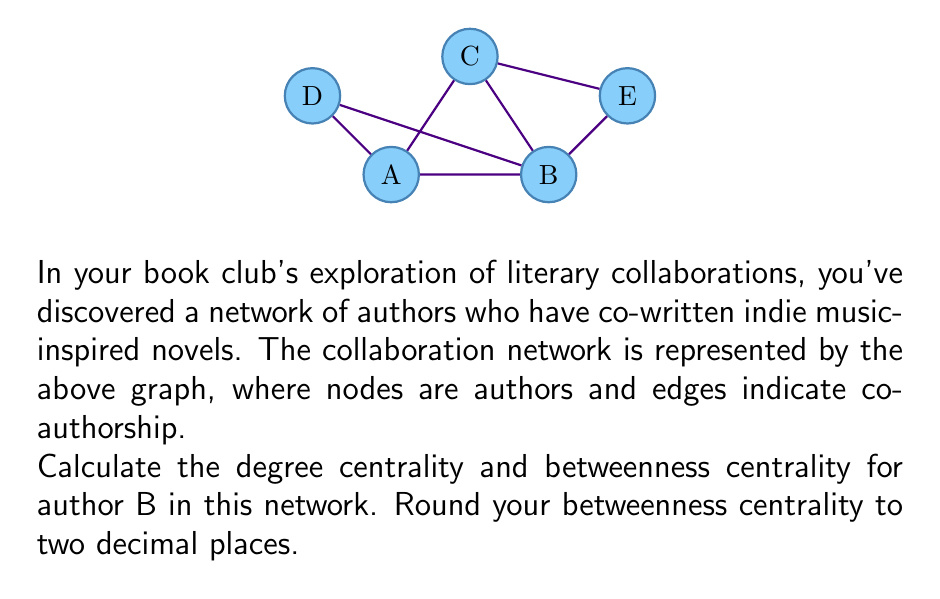Teach me how to tackle this problem. Let's approach this step-by-step:

1. Degree Centrality:
   The degree centrality is simply the number of connections an author has.
   Author B is connected to A, C, and E.
   Therefore, the degree centrality of B is 3.

2. Betweenness Centrality:
   Betweenness centrality measures how often a node appears on shortest paths between pairs of other nodes.

   First, let's count the total number of shortest paths and those that pass through B:

   A-C: 1 path (A-C), 0 through B
   A-D: 1 path (A-D), 0 through B
   A-E: 2 paths (A-B-E, A-C-E), 1 through B
   C-D: 2 paths (C-A-D, C-B-A-D), 1 through B
   C-E: 1 path (C-E), 0 through B
   D-E: 3 paths (D-A-B-E, D-A-C-E, D-B-E), 2 through B

   Now, let's calculate the betweenness centrality:

   $$BC(B) = \frac{1}{2} + \frac{1}{2} + \frac{2}{3} = \frac{5}{3} \approx 1.67$$

   The formula for each pair is (number of shortest paths through B) / (total number of shortest paths).
Answer: Degree centrality: 3, Betweenness centrality: 1.67 